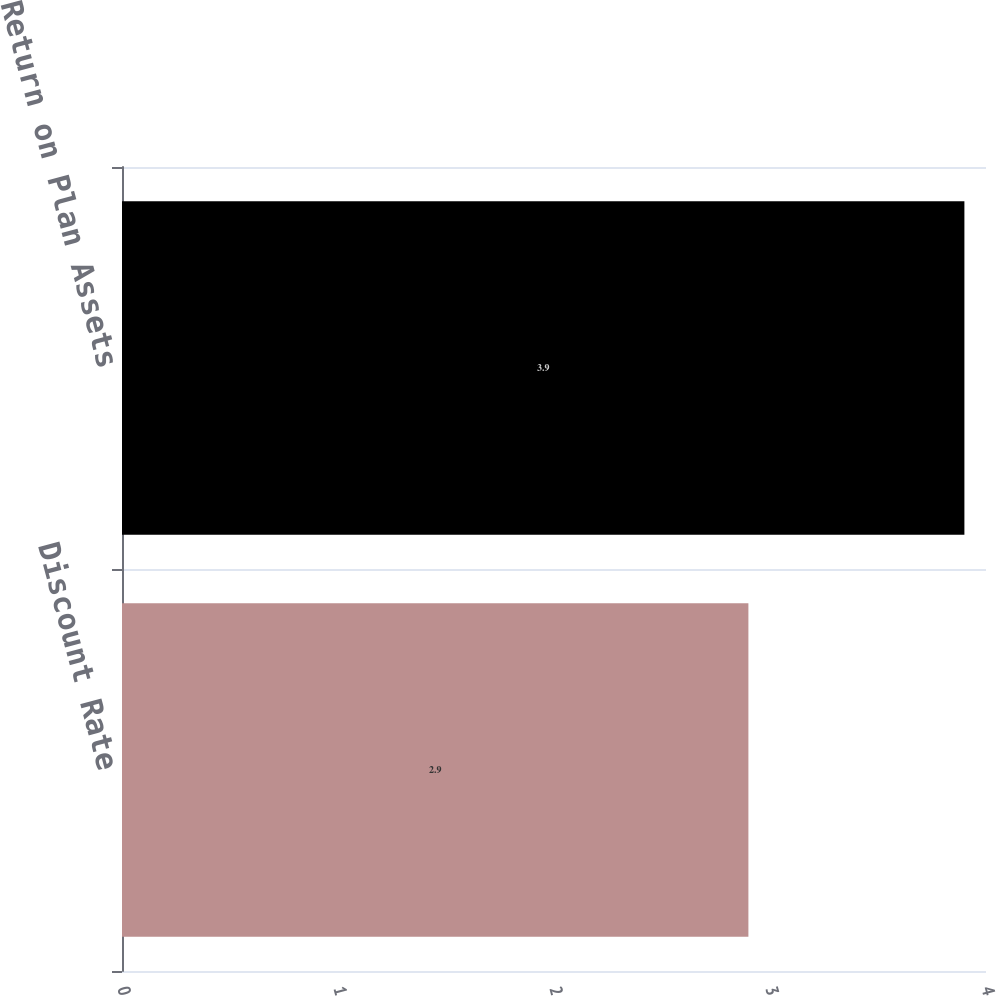<chart> <loc_0><loc_0><loc_500><loc_500><bar_chart><fcel>Discount Rate<fcel>Expected Return on Plan Assets<nl><fcel>2.9<fcel>3.9<nl></chart> 